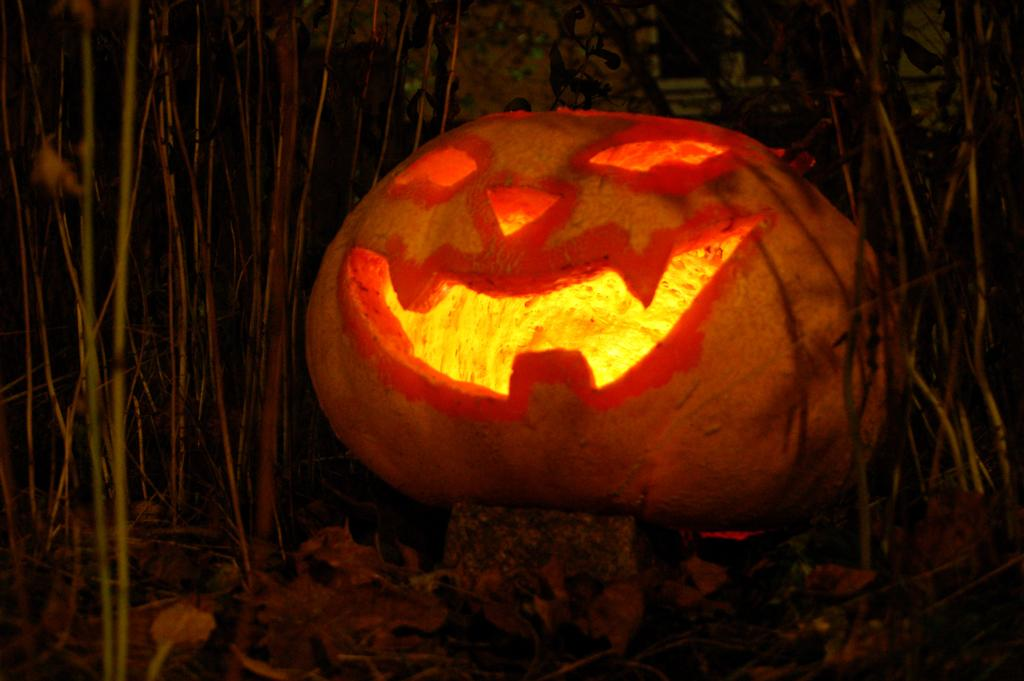What is the main subject of the image? The main subject of the image is a pumpkin with carvings. What is inside the pumpkin? There is light inside the pumpkin. What can be seen on the ground in the image? Dried leaves and stems are present on the ground in the image. How would you describe the overall lighting in the image? The background of the image is dark. What type of structure can be seen in the image? There is no structure present in the image; it features a carved pumpkin with light inside and dried leaves and stems on the ground. What shape is the square in the image? There is no square present in the image. 